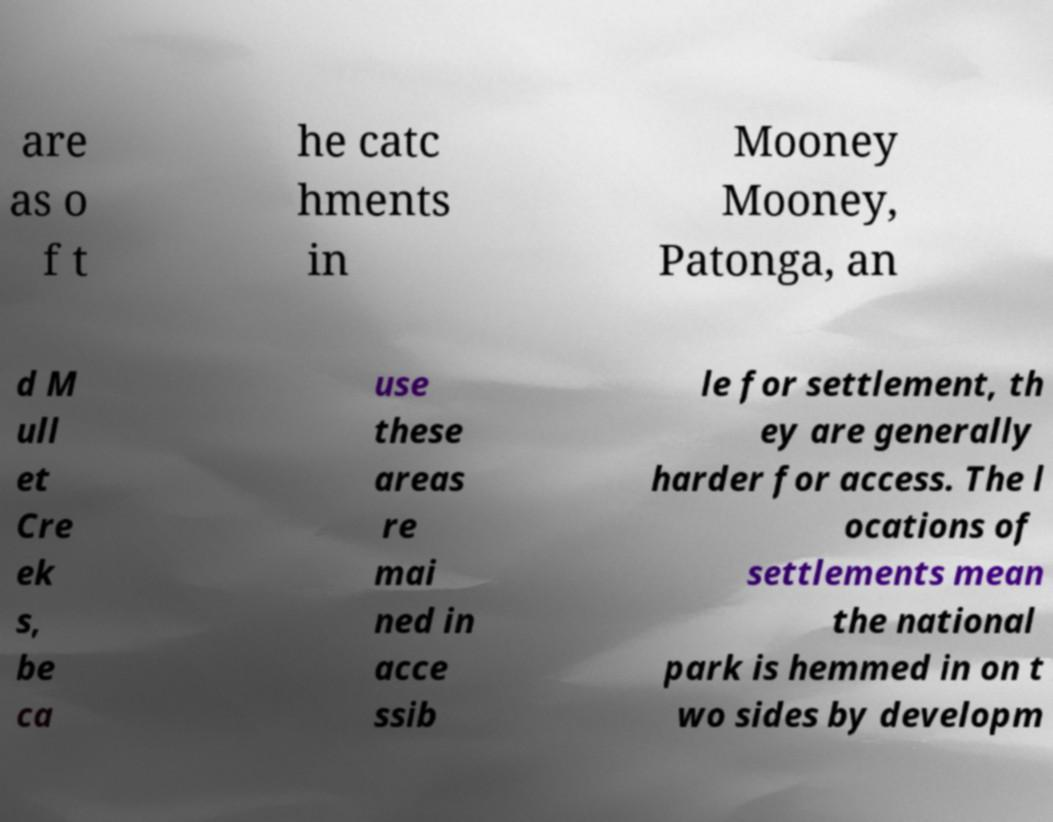Could you assist in decoding the text presented in this image and type it out clearly? are as o f t he catc hments in Mooney Mooney, Patonga, an d M ull et Cre ek s, be ca use these areas re mai ned in acce ssib le for settlement, th ey are generally harder for access. The l ocations of settlements mean the national park is hemmed in on t wo sides by developm 